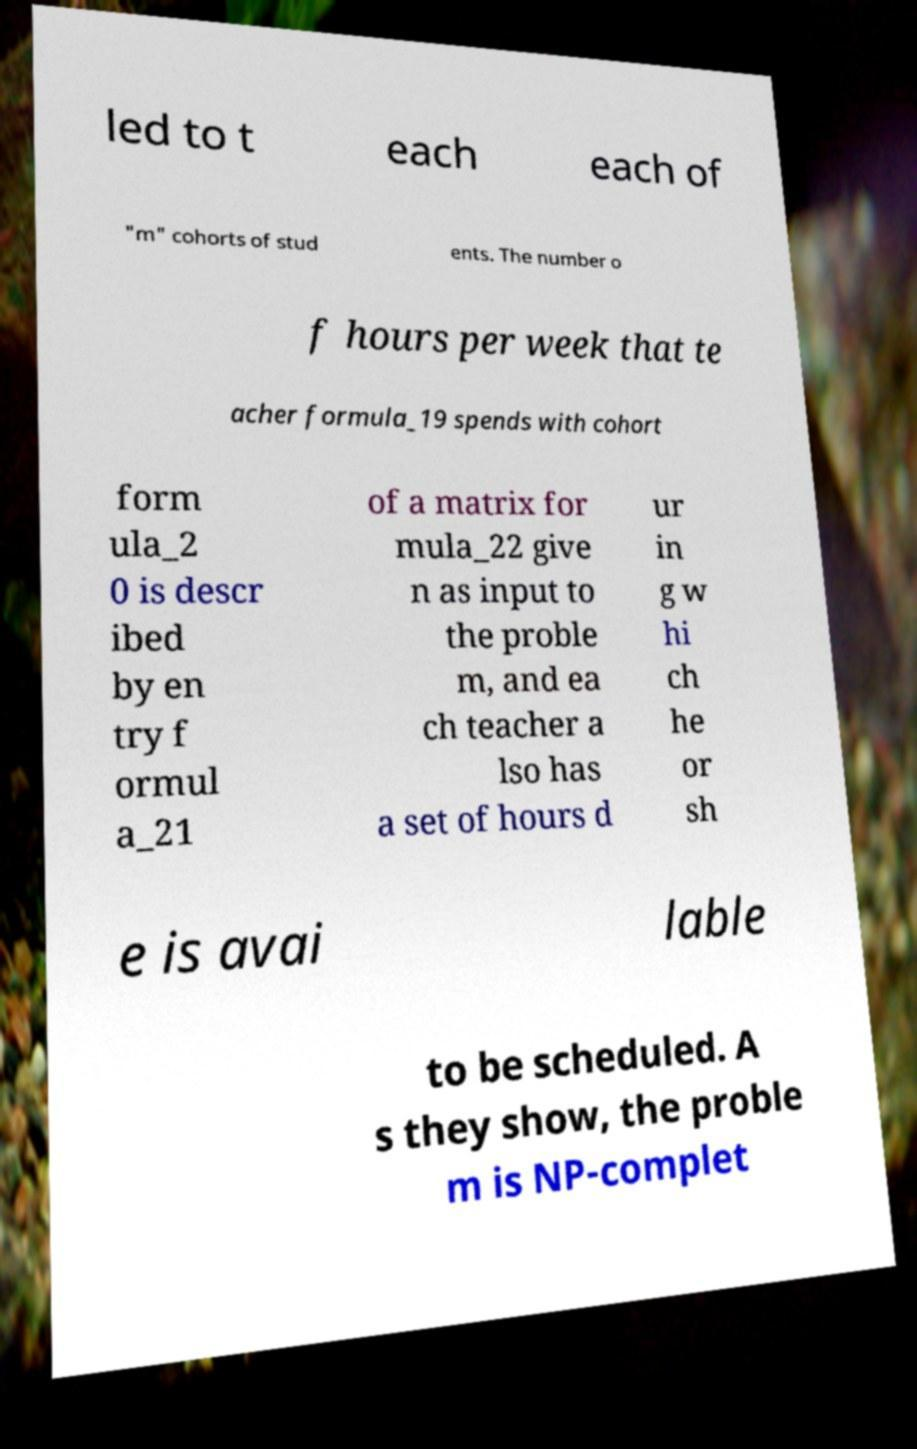Can you accurately transcribe the text from the provided image for me? led to t each each of "m" cohorts of stud ents. The number o f hours per week that te acher formula_19 spends with cohort form ula_2 0 is descr ibed by en try f ormul a_21 of a matrix for mula_22 give n as input to the proble m, and ea ch teacher a lso has a set of hours d ur in g w hi ch he or sh e is avai lable to be scheduled. A s they show, the proble m is NP-complet 